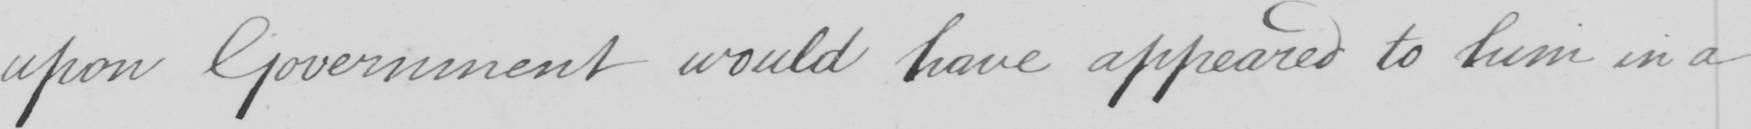What is written in this line of handwriting? upon Government would have appeared to him in a 